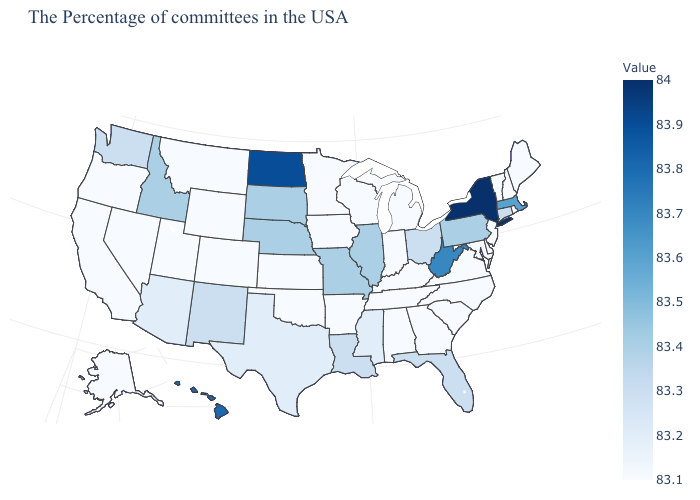Which states hav the highest value in the Northeast?
Concise answer only. New York. Is the legend a continuous bar?
Keep it brief. Yes. Does Illinois have a lower value than Hawaii?
Concise answer only. Yes. Does the map have missing data?
Short answer required. No. Which states have the lowest value in the USA?
Write a very short answer. Maine, Rhode Island, New Hampshire, Vermont, New Jersey, Delaware, Maryland, Virginia, North Carolina, South Carolina, Georgia, Michigan, Kentucky, Indiana, Alabama, Tennessee, Wisconsin, Arkansas, Minnesota, Iowa, Kansas, Oklahoma, Wyoming, Colorado, Utah, Montana, Nevada, California, Oregon, Alaska. Among the states that border Maryland , which have the lowest value?
Short answer required. Delaware, Virginia. 